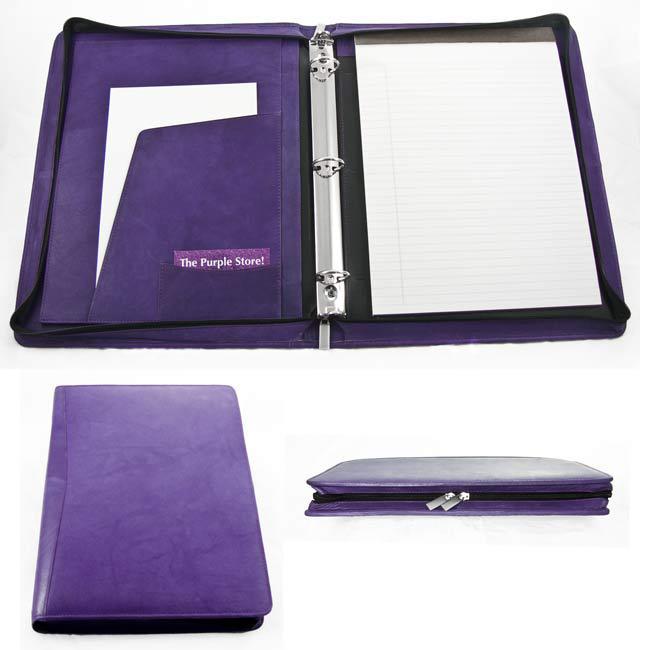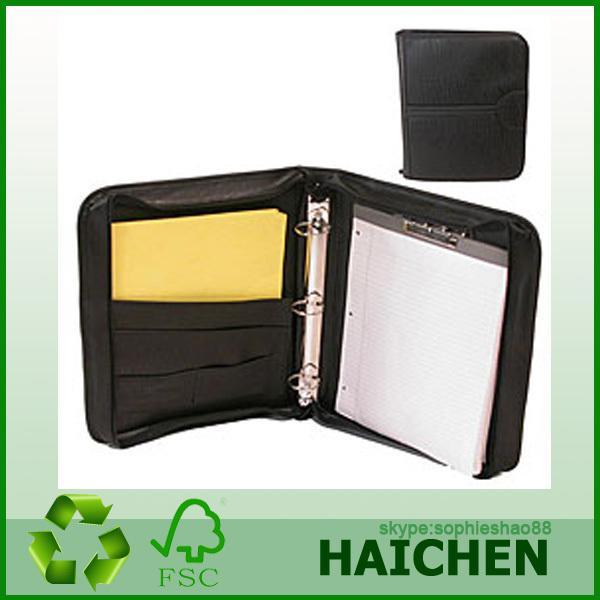The first image is the image on the left, the second image is the image on the right. Given the left and right images, does the statement "There is an example of a closed binder." hold true? Answer yes or no. Yes. 